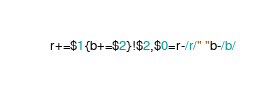<code> <loc_0><loc_0><loc_500><loc_500><_Awk_>r+=$1{b+=$2}!$2,$0=r-/r/" "b-/b/</code> 